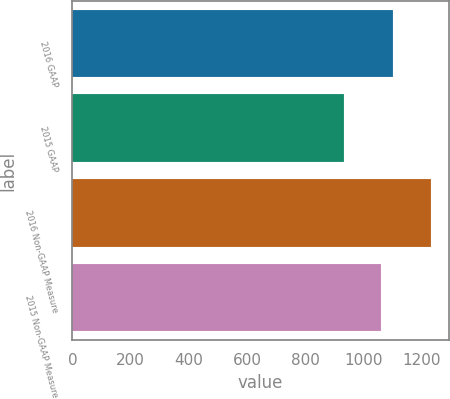<chart> <loc_0><loc_0><loc_500><loc_500><bar_chart><fcel>2016 GAAP<fcel>2015 GAAP<fcel>2016 Non-GAAP Measure<fcel>2015 Non-GAAP Measure<nl><fcel>1099.5<fcel>933.3<fcel>1230.3<fcel>1060.8<nl></chart> 